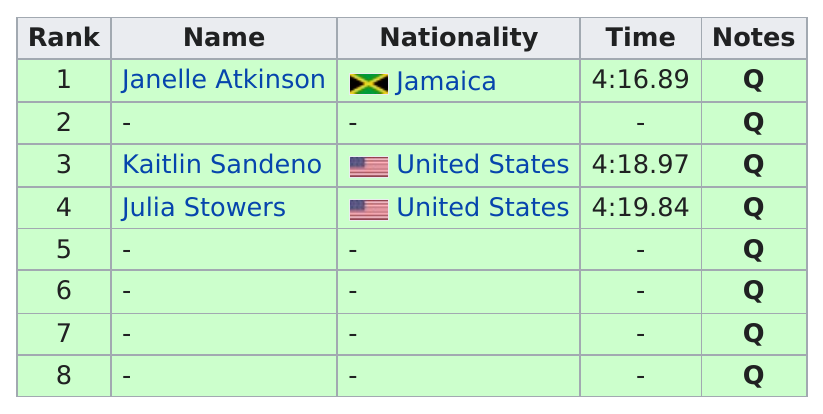Mention a couple of crucial points in this snapshot. The average time for the Americans was 4 minutes and 19.41 seconds. Kaitlin Sandeno was ranked below Julia Stowers, who was ranked below her in the standings. Of the ranks, approximately 5 have no name. It is Janelle Atkinson, who is the only person from Jamaica to have ranked. Besides Julia Stowers, the other American listed is Kaitlin Sandeno. 